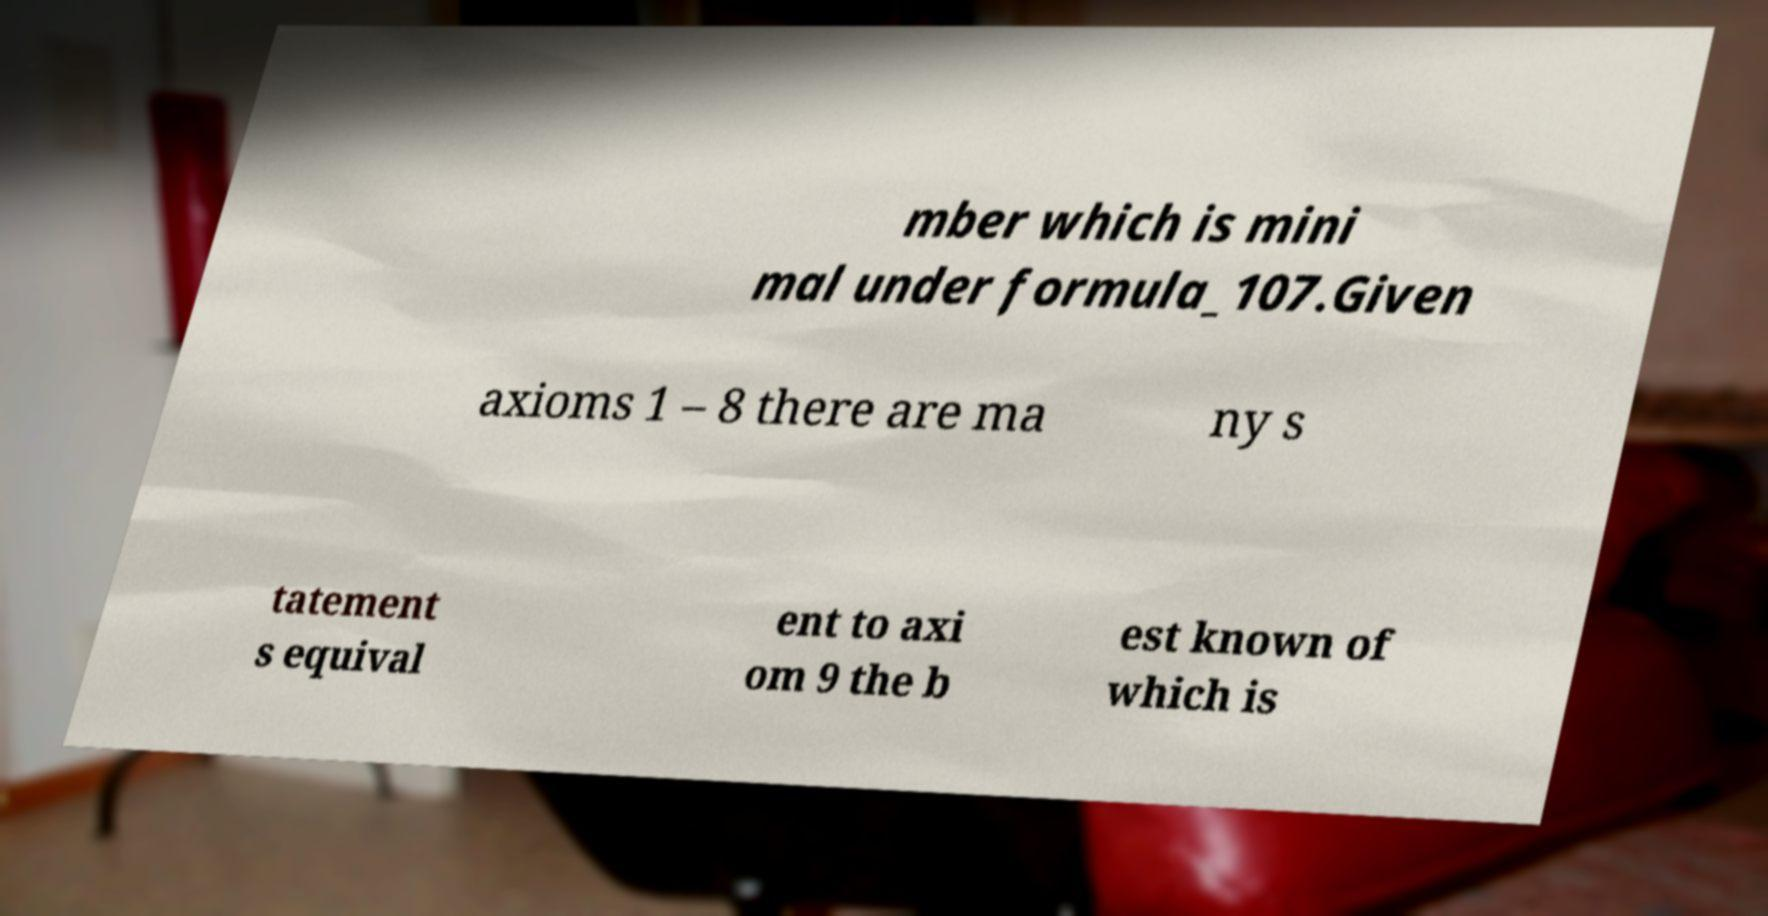Could you assist in decoding the text presented in this image and type it out clearly? mber which is mini mal under formula_107.Given axioms 1 – 8 there are ma ny s tatement s equival ent to axi om 9 the b est known of which is 